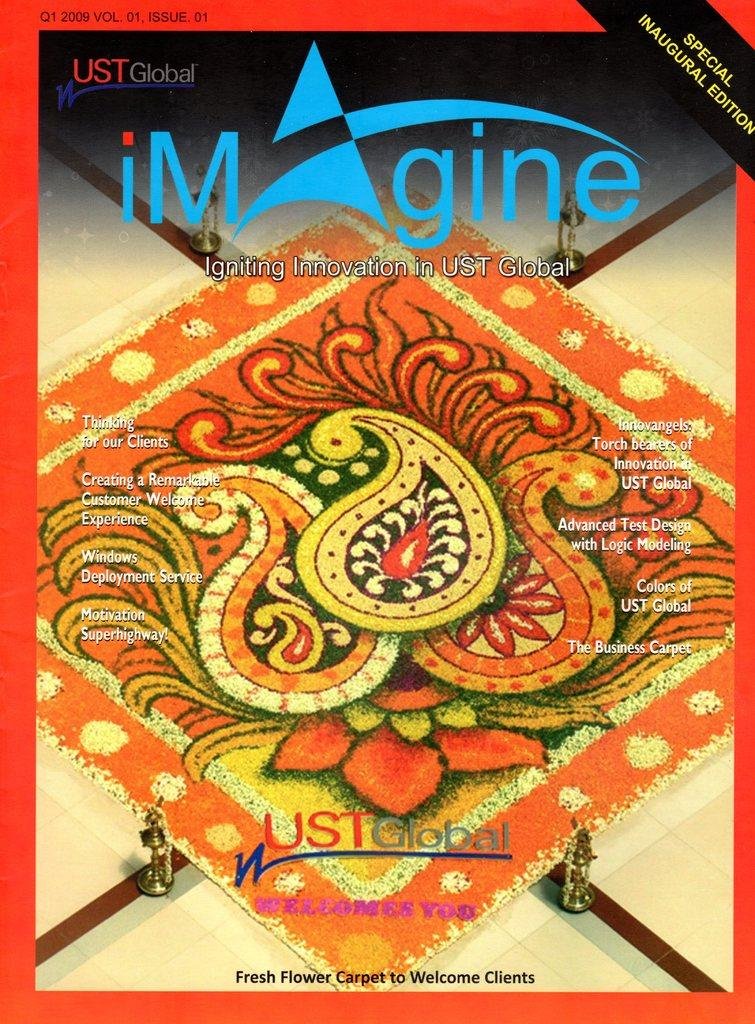<image>
Create a compact narrative representing the image presented. The UST Global special inaugural edition Imagine cover. 